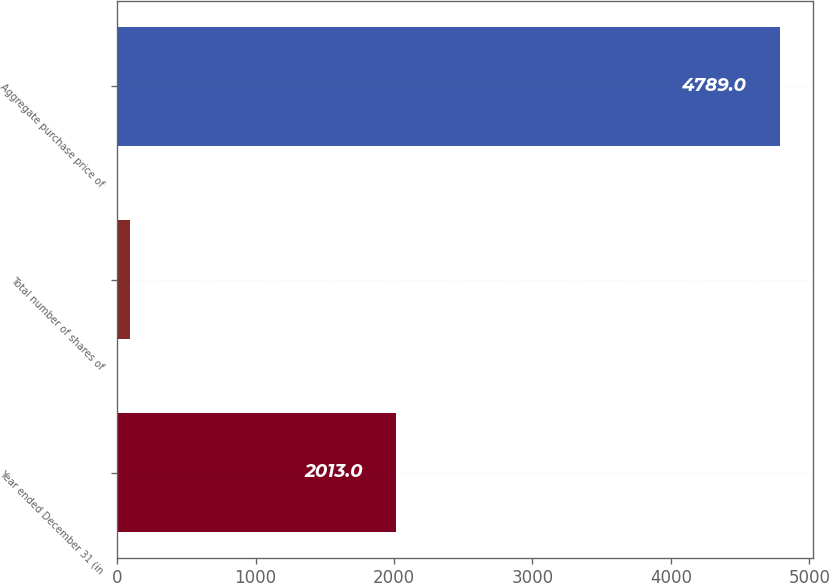Convert chart to OTSL. <chart><loc_0><loc_0><loc_500><loc_500><bar_chart><fcel>Year ended December 31 (in<fcel>Total number of shares of<fcel>Aggregate purchase price of<nl><fcel>2013<fcel>96.1<fcel>4789<nl></chart> 